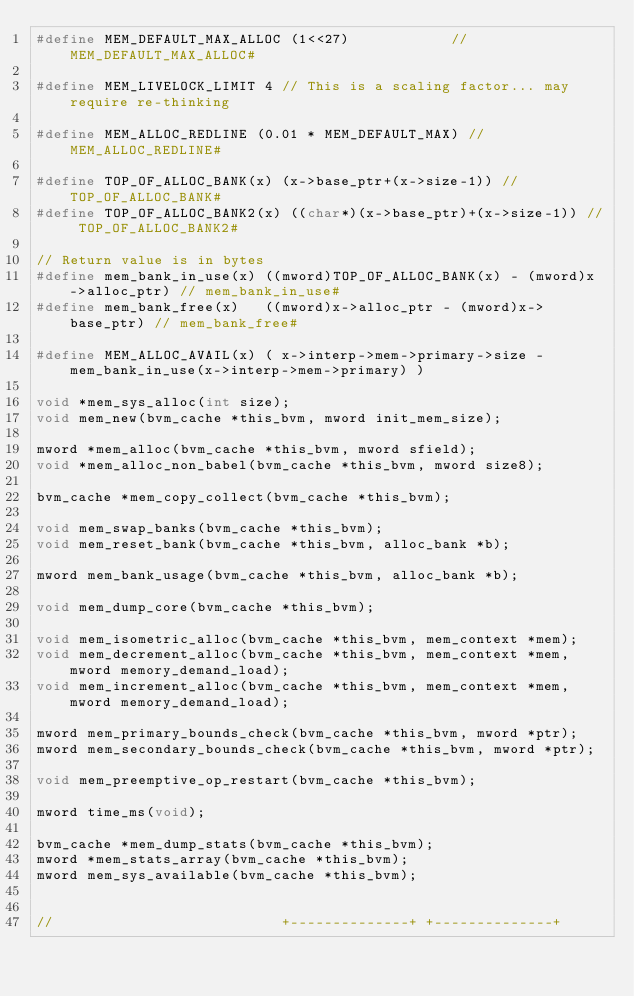<code> <loc_0><loc_0><loc_500><loc_500><_C_>#define MEM_DEFAULT_MAX_ALLOC (1<<27)            // MEM_DEFAULT_MAX_ALLOC#

#define MEM_LIVELOCK_LIMIT 4 // This is a scaling factor... may require re-thinking

#define MEM_ALLOC_REDLINE (0.01 * MEM_DEFAULT_MAX) // MEM_ALLOC_REDLINE#

#define TOP_OF_ALLOC_BANK(x) (x->base_ptr+(x->size-1)) // TOP_OF_ALLOC_BANK#
#define TOP_OF_ALLOC_BANK2(x) ((char*)(x->base_ptr)+(x->size-1)) // TOP_OF_ALLOC_BANK2#

// Return value is in bytes
#define mem_bank_in_use(x) ((mword)TOP_OF_ALLOC_BANK(x) - (mword)x->alloc_ptr) // mem_bank_in_use#
#define mem_bank_free(x)   ((mword)x->alloc_ptr - (mword)x->base_ptr) // mem_bank_free#

#define MEM_ALLOC_AVAIL(x) ( x->interp->mem->primary->size - mem_bank_in_use(x->interp->mem->primary) )

void *mem_sys_alloc(int size);
void mem_new(bvm_cache *this_bvm, mword init_mem_size);

mword *mem_alloc(bvm_cache *this_bvm, mword sfield);
void *mem_alloc_non_babel(bvm_cache *this_bvm, mword size8);

bvm_cache *mem_copy_collect(bvm_cache *this_bvm);

void mem_swap_banks(bvm_cache *this_bvm);
void mem_reset_bank(bvm_cache *this_bvm, alloc_bank *b);

mword mem_bank_usage(bvm_cache *this_bvm, alloc_bank *b);

void mem_dump_core(bvm_cache *this_bvm);

void mem_isometric_alloc(bvm_cache *this_bvm, mem_context *mem);
void mem_decrement_alloc(bvm_cache *this_bvm, mem_context *mem, mword memory_demand_load);
void mem_increment_alloc(bvm_cache *this_bvm, mem_context *mem, mword memory_demand_load);

mword mem_primary_bounds_check(bvm_cache *this_bvm, mword *ptr);
mword mem_secondary_bounds_check(bvm_cache *this_bvm, mword *ptr);

void mem_preemptive_op_restart(bvm_cache *this_bvm);

mword time_ms(void);

bvm_cache *mem_dump_stats(bvm_cache *this_bvm);
mword *mem_stats_array(bvm_cache *this_bvm);
mword mem_sys_available(bvm_cache *this_bvm);


//                           +--------------+ +--------------+</code> 